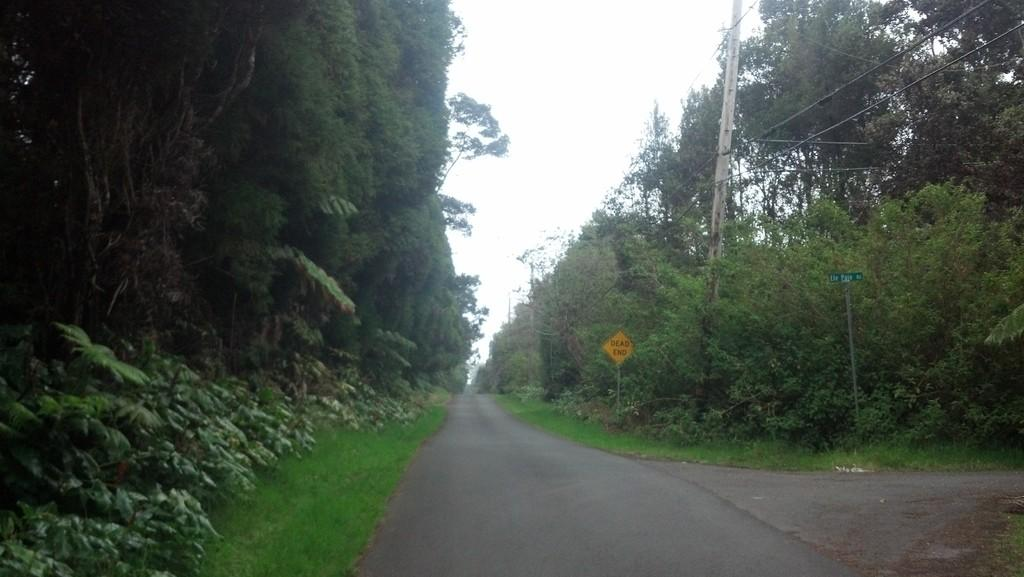What type of vegetation can be seen in the image? There are trees, plants, and grass in the image. What man-made structures are present in the image? There are sign boards and electric poles in the image. Are there any cables visible in the image? Yes, there are cables in the image. What part of the natural environment is visible in the image? The sky is visible in the image. What type of calendar is hanging on the tree in the image? There is no calendar present in the image; it features trees, plants, grass, sign boards, electric poles, cables, and the sky. 